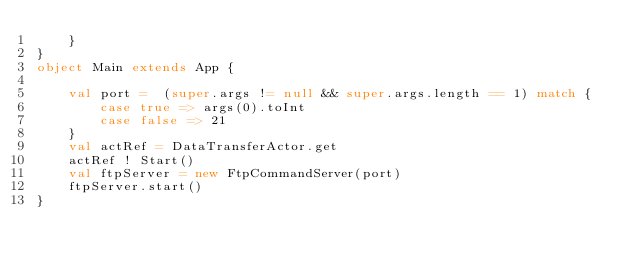Convert code to text. <code><loc_0><loc_0><loc_500><loc_500><_Scala_>    }
}
object Main extends App {

    val port =  (super.args != null && super.args.length == 1) match {
        case true => args(0).toInt
        case false => 21
    }
    val actRef = DataTransferActor.get
    actRef ! Start()
    val ftpServer = new FtpCommandServer(port)
    ftpServer.start()
}
</code> 